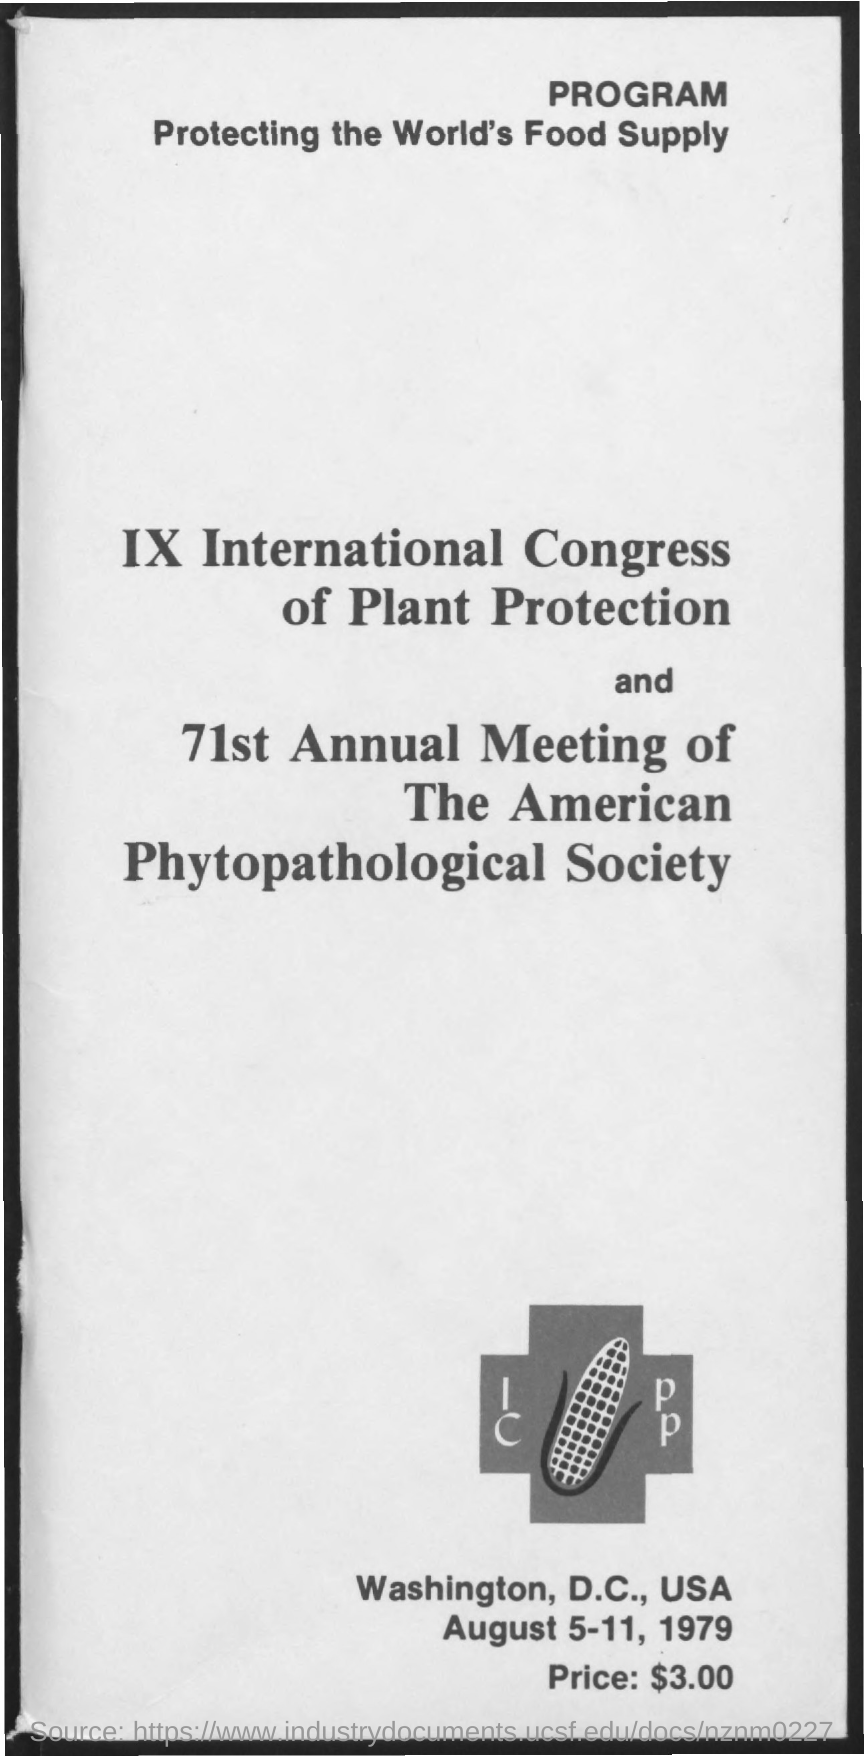Outline some significant characteristics in this image. The program known for protecting the world's food supply is named. The price mentioned on the given page is $3.00. The date mentioned in the given page is August 5-11, 1979. 